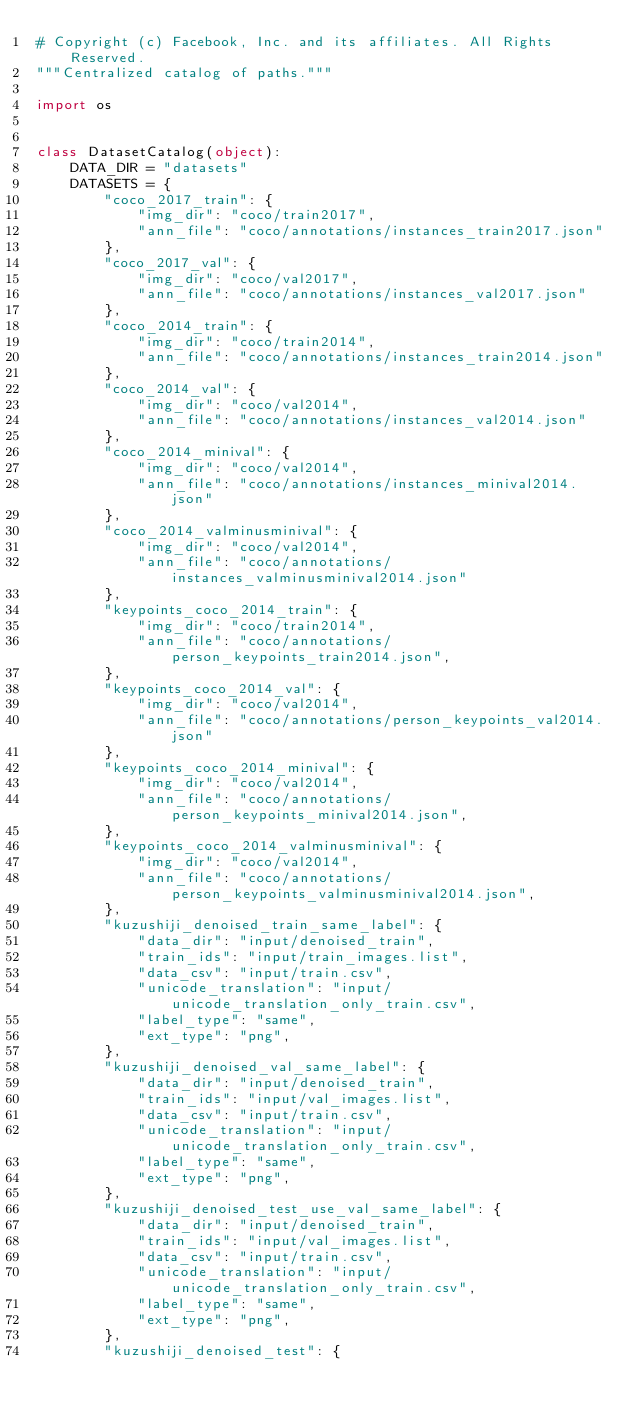Convert code to text. <code><loc_0><loc_0><loc_500><loc_500><_Python_># Copyright (c) Facebook, Inc. and its affiliates. All Rights Reserved.
"""Centralized catalog of paths."""

import os


class DatasetCatalog(object):
    DATA_DIR = "datasets"
    DATASETS = {
        "coco_2017_train": {
            "img_dir": "coco/train2017",
            "ann_file": "coco/annotations/instances_train2017.json"
        },
        "coco_2017_val": {
            "img_dir": "coco/val2017",
            "ann_file": "coco/annotations/instances_val2017.json"
        },
        "coco_2014_train": {
            "img_dir": "coco/train2014",
            "ann_file": "coco/annotations/instances_train2014.json"
        },
        "coco_2014_val": {
            "img_dir": "coco/val2014",
            "ann_file": "coco/annotations/instances_val2014.json"
        },
        "coco_2014_minival": {
            "img_dir": "coco/val2014",
            "ann_file": "coco/annotations/instances_minival2014.json"
        },
        "coco_2014_valminusminival": {
            "img_dir": "coco/val2014",
            "ann_file": "coco/annotations/instances_valminusminival2014.json"
        },
        "keypoints_coco_2014_train": {
            "img_dir": "coco/train2014",
            "ann_file": "coco/annotations/person_keypoints_train2014.json",
        },
        "keypoints_coco_2014_val": {
            "img_dir": "coco/val2014",
            "ann_file": "coco/annotations/person_keypoints_val2014.json"
        },
        "keypoints_coco_2014_minival": {
            "img_dir": "coco/val2014",
            "ann_file": "coco/annotations/person_keypoints_minival2014.json",
        },
        "keypoints_coco_2014_valminusminival": {
            "img_dir": "coco/val2014",
            "ann_file": "coco/annotations/person_keypoints_valminusminival2014.json",
        },
        "kuzushiji_denoised_train_same_label": {
            "data_dir": "input/denoised_train",
            "train_ids": "input/train_images.list",
            "data_csv": "input/train.csv",
            "unicode_translation": "input/unicode_translation_only_train.csv",
            "label_type": "same",
            "ext_type": "png",
        },
        "kuzushiji_denoised_val_same_label": {
            "data_dir": "input/denoised_train",
            "train_ids": "input/val_images.list",
            "data_csv": "input/train.csv",
            "unicode_translation": "input/unicode_translation_only_train.csv",
            "label_type": "same",
            "ext_type": "png",
        },
        "kuzushiji_denoised_test_use_val_same_label": {
            "data_dir": "input/denoised_train",
            "train_ids": "input/val_images.list",
            "data_csv": "input/train.csv",
            "unicode_translation": "input/unicode_translation_only_train.csv",
            "label_type": "same",
            "ext_type": "png",
        },
        "kuzushiji_denoised_test": {</code> 